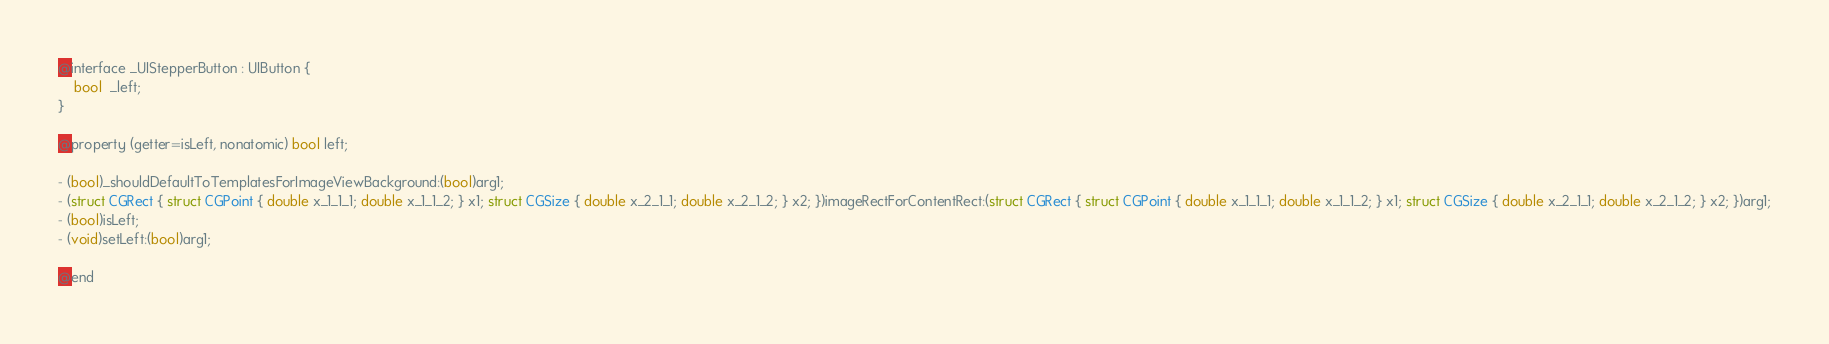<code> <loc_0><loc_0><loc_500><loc_500><_C_>
@interface _UIStepperButton : UIButton {
    bool  _left;
}

@property (getter=isLeft, nonatomic) bool left;

- (bool)_shouldDefaultToTemplatesForImageViewBackground:(bool)arg1;
- (struct CGRect { struct CGPoint { double x_1_1_1; double x_1_1_2; } x1; struct CGSize { double x_2_1_1; double x_2_1_2; } x2; })imageRectForContentRect:(struct CGRect { struct CGPoint { double x_1_1_1; double x_1_1_2; } x1; struct CGSize { double x_2_1_1; double x_2_1_2; } x2; })arg1;
- (bool)isLeft;
- (void)setLeft:(bool)arg1;

@end
</code> 